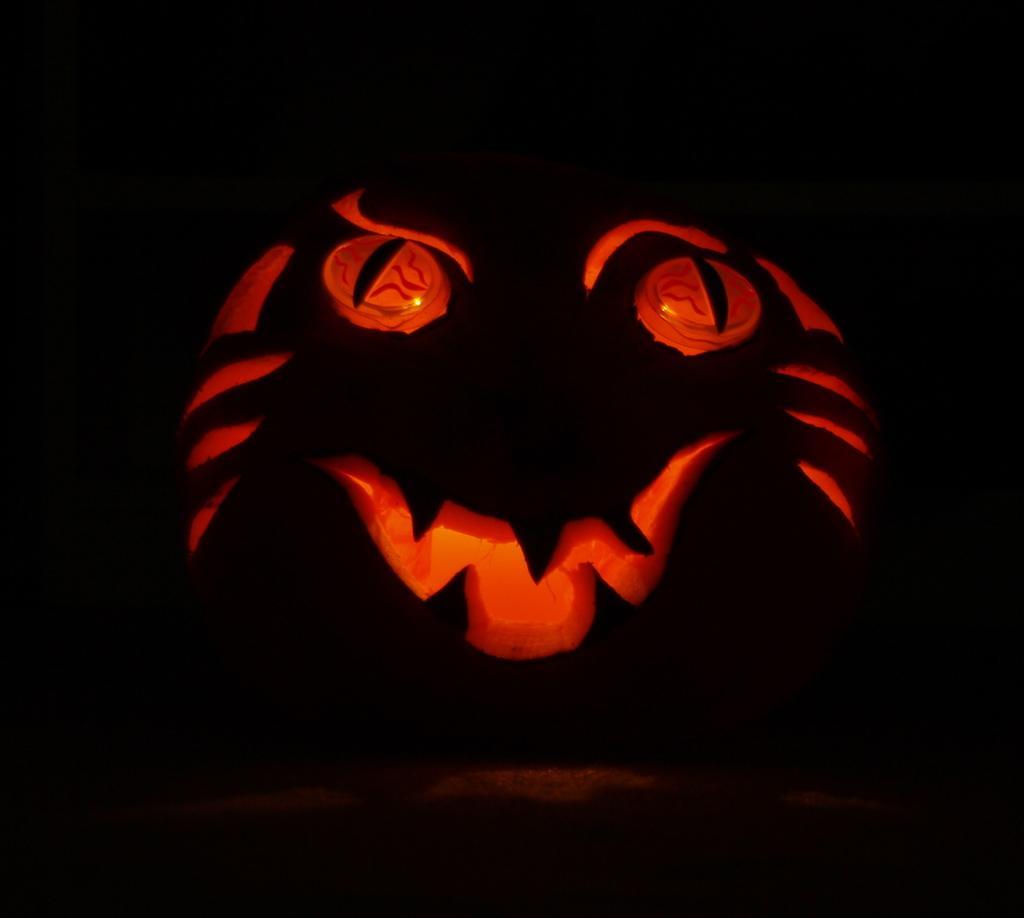Could you give a brief overview of what you see in this image? In the image there is a halloween pumpkin lantern. And there is a dark background. 